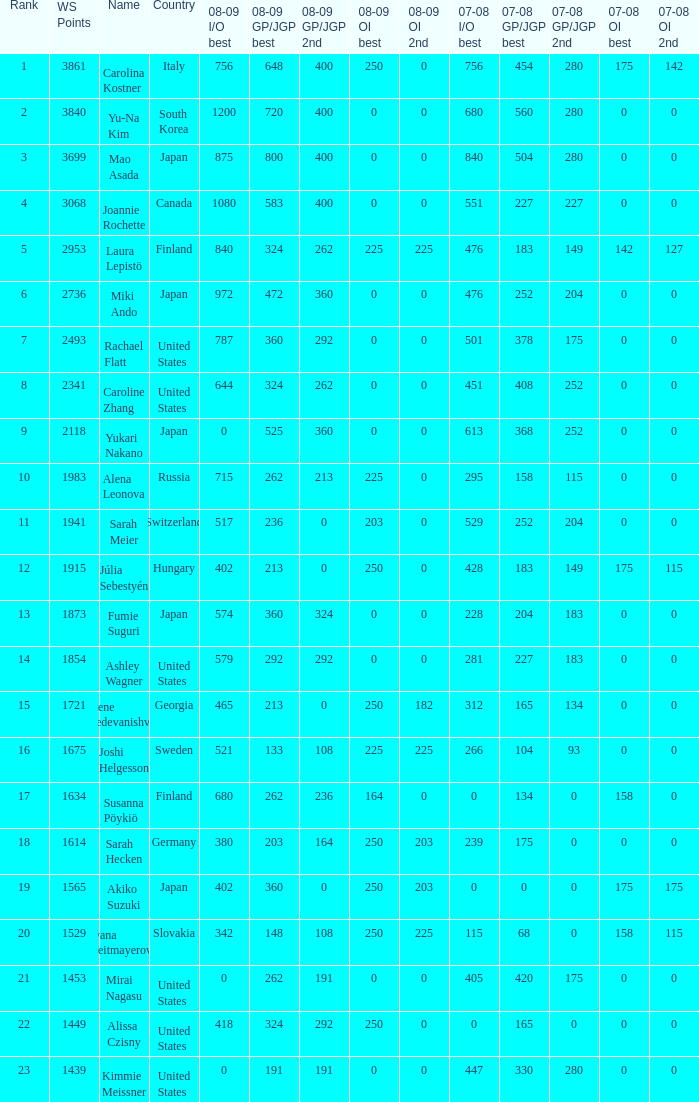What is the complete 07-08 gp/jgp 2nd position named mao asada? 280.0. 